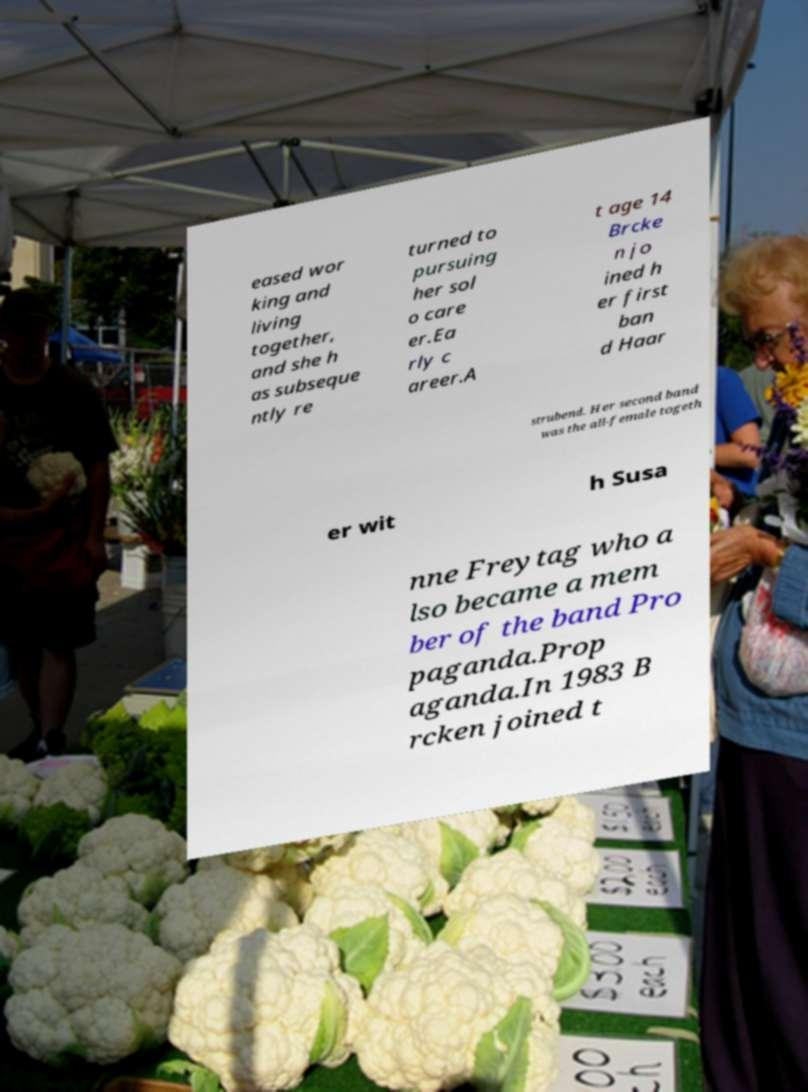I need the written content from this picture converted into text. Can you do that? eased wor king and living together, and she h as subseque ntly re turned to pursuing her sol o care er.Ea rly c areer.A t age 14 Brcke n jo ined h er first ban d Haar strubend. Her second band was the all-female togeth er wit h Susa nne Freytag who a lso became a mem ber of the band Pro paganda.Prop aganda.In 1983 B rcken joined t 